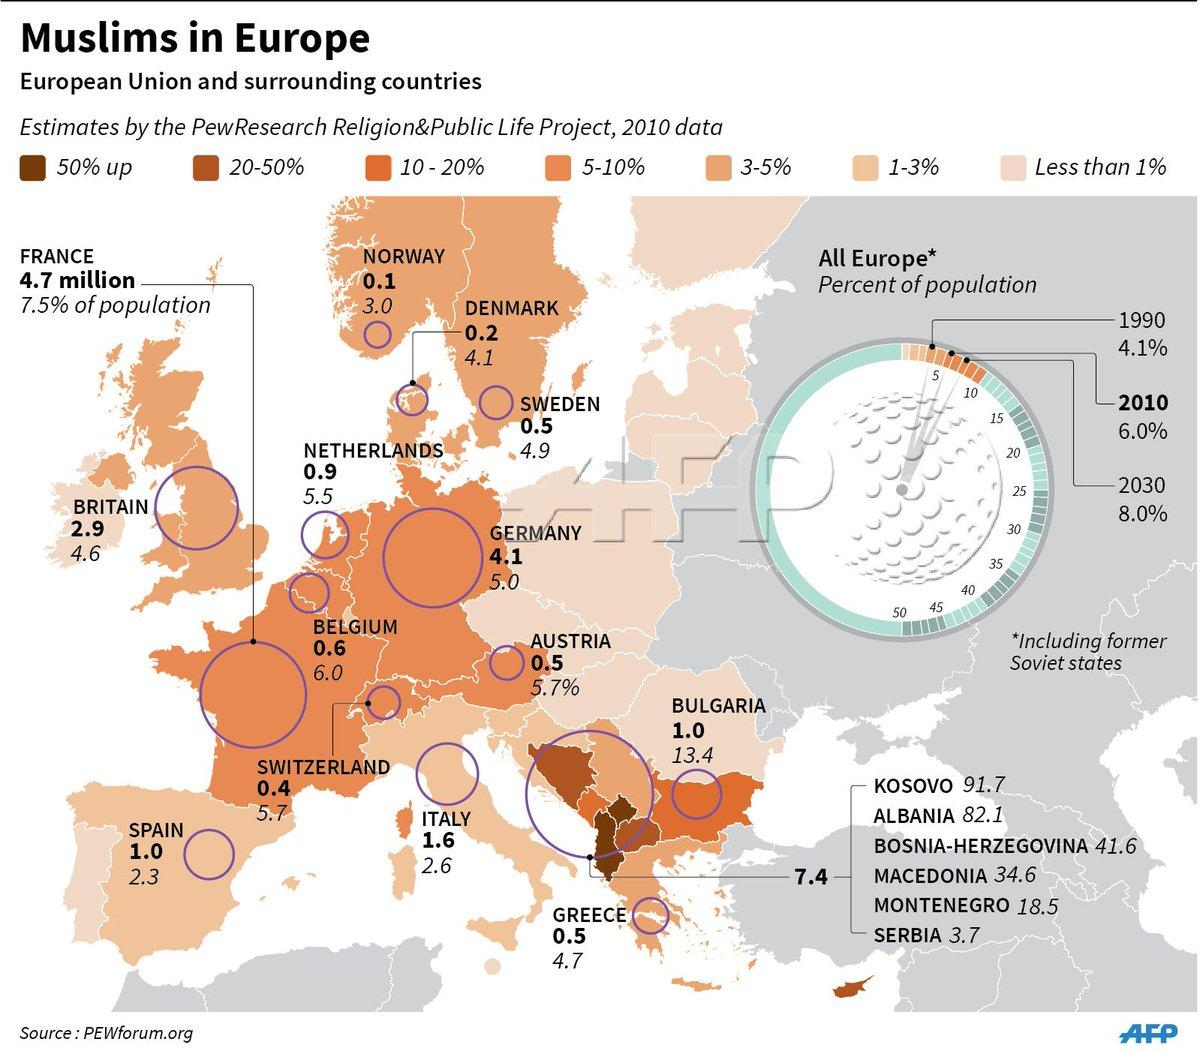Specify some key components in this picture. The total Muslim population from Germany and Austria taken together is approximately 4.6 million. According to recent estimates, approximately 3% of the population of Norway is Muslim. The total Muslim population of Britain and France taken together is approximately 7.6 million. The percentage of people in Italy who are Muslim is approximately 2.6%. The total Muslim population from Spain and Greece taken together is approximately 1.5 million. 